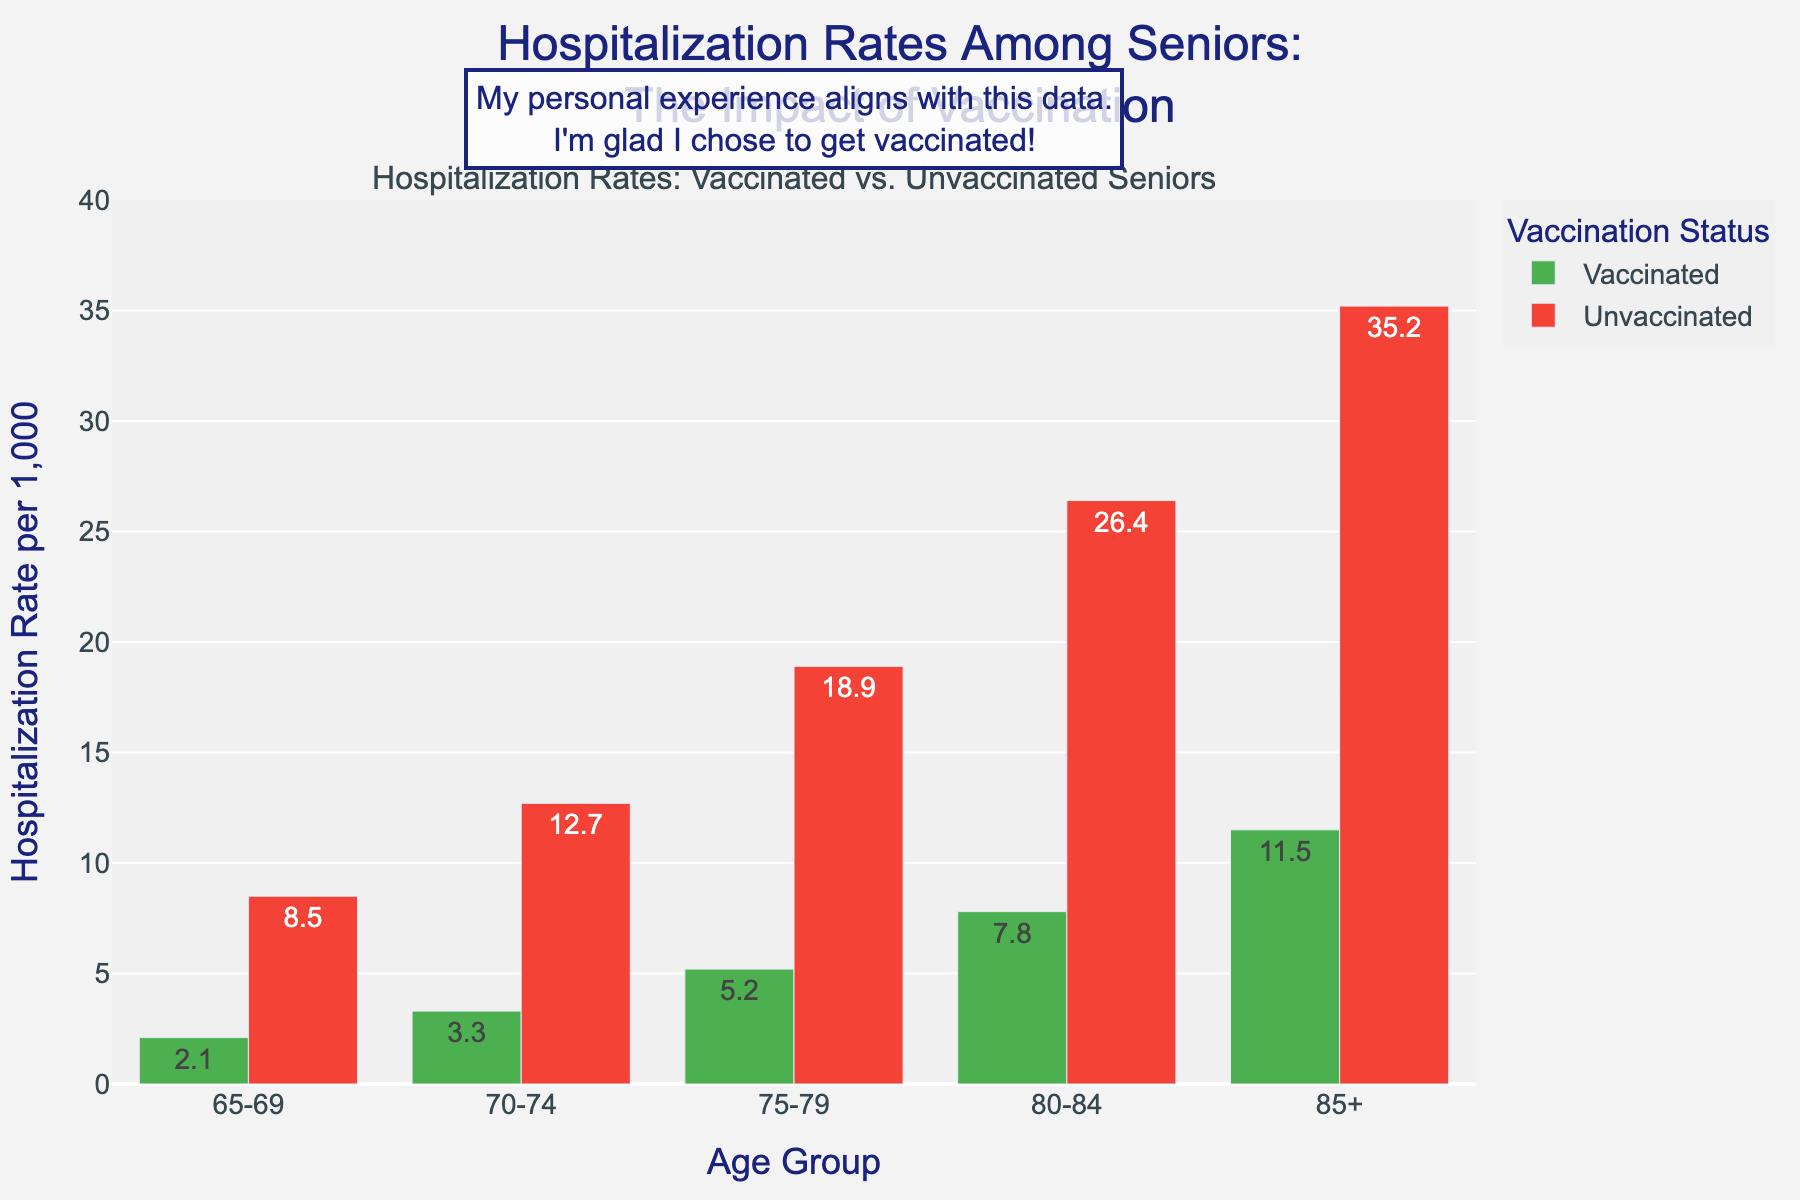What is the hospitalization rate for vaccinated seniors aged 75-79? To find the hospitalization rate for vaccinated seniors aged 75-79, look at the height of the green bar labeled "75-79". The text on the bar shows the rate.
Answer: 5.2 Which age group shows the biggest difference in hospitalization rates between vaccinated and unvaccinated seniors? To determine the age group with the biggest difference, subtract the hospitalization rate for vaccinated seniors from the rate for unvaccinated seniors in each age group. The group with the highest difference is the one with the largest gap between the red and green bars. For the age 85+, the difference is 35.2 - 11.5 = 23.7, which is the highest.
Answer: 85+ How does the trend in hospitalization rates change with age for vaccinated seniors? Look at the green bars for each age group. As you move from left (younger) to right (older), observe if the heights of these bars increase or decrease. The heights increase steadily with age, indicating higher rates for older age groups.
Answer: Increases How much higher is the hospitalization rate for unvaccinated seniors aged 70-74 compared to vaccinated seniors of the same age group? Compare the red bar to the green bar for the age group 70-74. The red bar shows 12.7 and the green bar shows 3.3. Subtract the green bar value from the red bar value: 12.7 - 3.3 = 9.4.
Answer: 9.4 What is the average hospitalization rate for vaccinated seniors across all age groups? To calculate the average, add up the rates for vaccinated seniors in all age groups and divide by the number of age groups. The rates are 2.1, 3.3, 5.2, 7.8, and 11.5. The sum is 2.1 + 3.3 + 5.2 + 7.8 + 11.5 = 29.9. There are 5 age groups, so the average is 29.9 / 5.
Answer: 5.98 Which age group has the highest hospitalization rate for vaccinated seniors? Look at the green bars in the chart and find the highest one. The green bar for the age group 85+ is the tallest, showing the highest rate.
Answer: 85+ By how much do unvaccinated seniors aged 80-84 have a higher hospitalization rate compared to vaccinated seniors aged 80-84? Compare the red bar and the green bar for the age group 80-84. The red bar shows 26.4 and the green bar shows 7.8. Subtract the green bar value from the red bar value: 26.4 - 7.8 = 18.6.
Answer: 18.6 